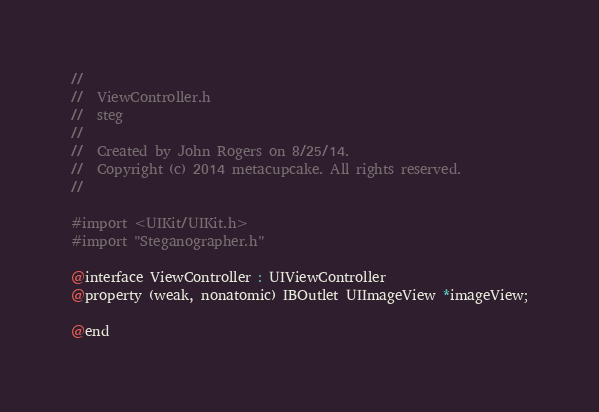Convert code to text. <code><loc_0><loc_0><loc_500><loc_500><_C_>//
//  ViewController.h
//  steg
//
//  Created by John Rogers on 8/25/14.
//  Copyright (c) 2014 metacupcake. All rights reserved.
//

#import <UIKit/UIKit.h>
#import "Steganographer.h"

@interface ViewController : UIViewController
@property (weak, nonatomic) IBOutlet UIImageView *imageView;

@end
</code> 